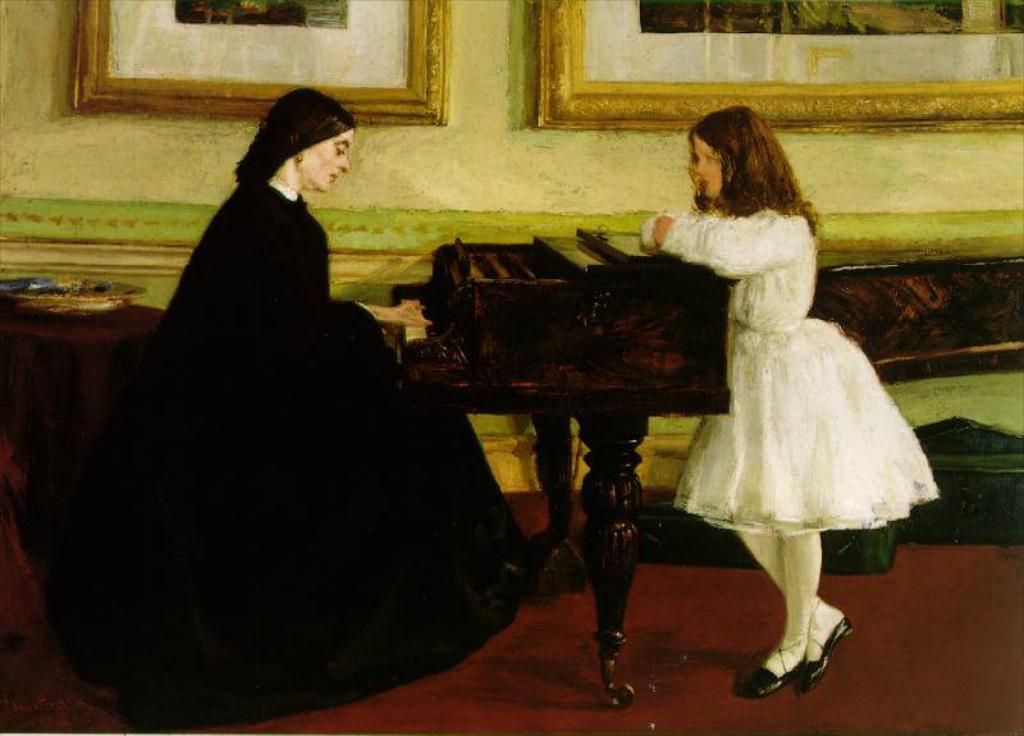Could you give a brief overview of what you see in this image? In the image we can see there is a woman who is sitting on a chair and playing piano and another girl is standing in front of the piano. 